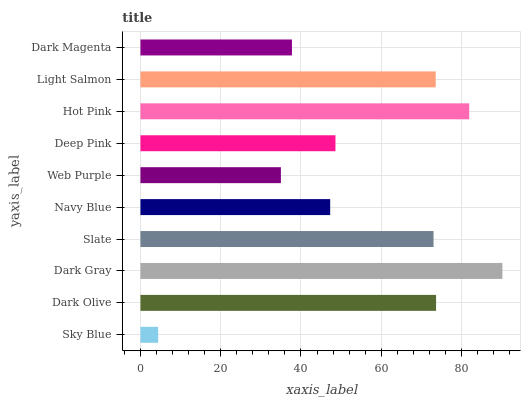Is Sky Blue the minimum?
Answer yes or no. Yes. Is Dark Gray the maximum?
Answer yes or no. Yes. Is Dark Olive the minimum?
Answer yes or no. No. Is Dark Olive the maximum?
Answer yes or no. No. Is Dark Olive greater than Sky Blue?
Answer yes or no. Yes. Is Sky Blue less than Dark Olive?
Answer yes or no. Yes. Is Sky Blue greater than Dark Olive?
Answer yes or no. No. Is Dark Olive less than Sky Blue?
Answer yes or no. No. Is Slate the high median?
Answer yes or no. Yes. Is Deep Pink the low median?
Answer yes or no. Yes. Is Deep Pink the high median?
Answer yes or no. No. Is Web Purple the low median?
Answer yes or no. No. 